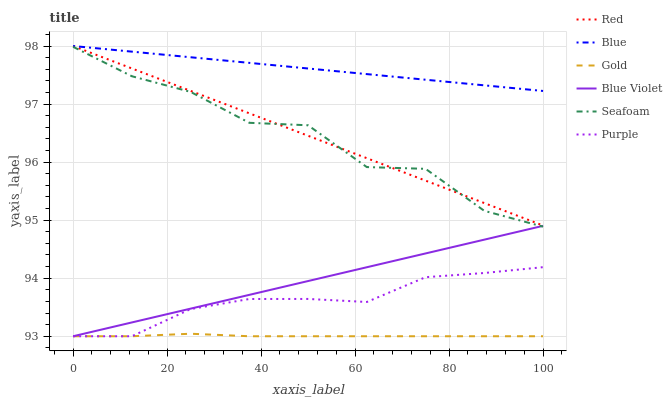Does Gold have the minimum area under the curve?
Answer yes or no. Yes. Does Blue have the maximum area under the curve?
Answer yes or no. Yes. Does Purple have the minimum area under the curve?
Answer yes or no. No. Does Purple have the maximum area under the curve?
Answer yes or no. No. Is Red the smoothest?
Answer yes or no. Yes. Is Seafoam the roughest?
Answer yes or no. Yes. Is Gold the smoothest?
Answer yes or no. No. Is Gold the roughest?
Answer yes or no. No. Does Gold have the lowest value?
Answer yes or no. Yes. Does Seafoam have the lowest value?
Answer yes or no. No. Does Red have the highest value?
Answer yes or no. Yes. Does Purple have the highest value?
Answer yes or no. No. Is Seafoam less than Blue?
Answer yes or no. Yes. Is Blue greater than Purple?
Answer yes or no. Yes. Does Gold intersect Blue Violet?
Answer yes or no. Yes. Is Gold less than Blue Violet?
Answer yes or no. No. Is Gold greater than Blue Violet?
Answer yes or no. No. Does Seafoam intersect Blue?
Answer yes or no. No. 